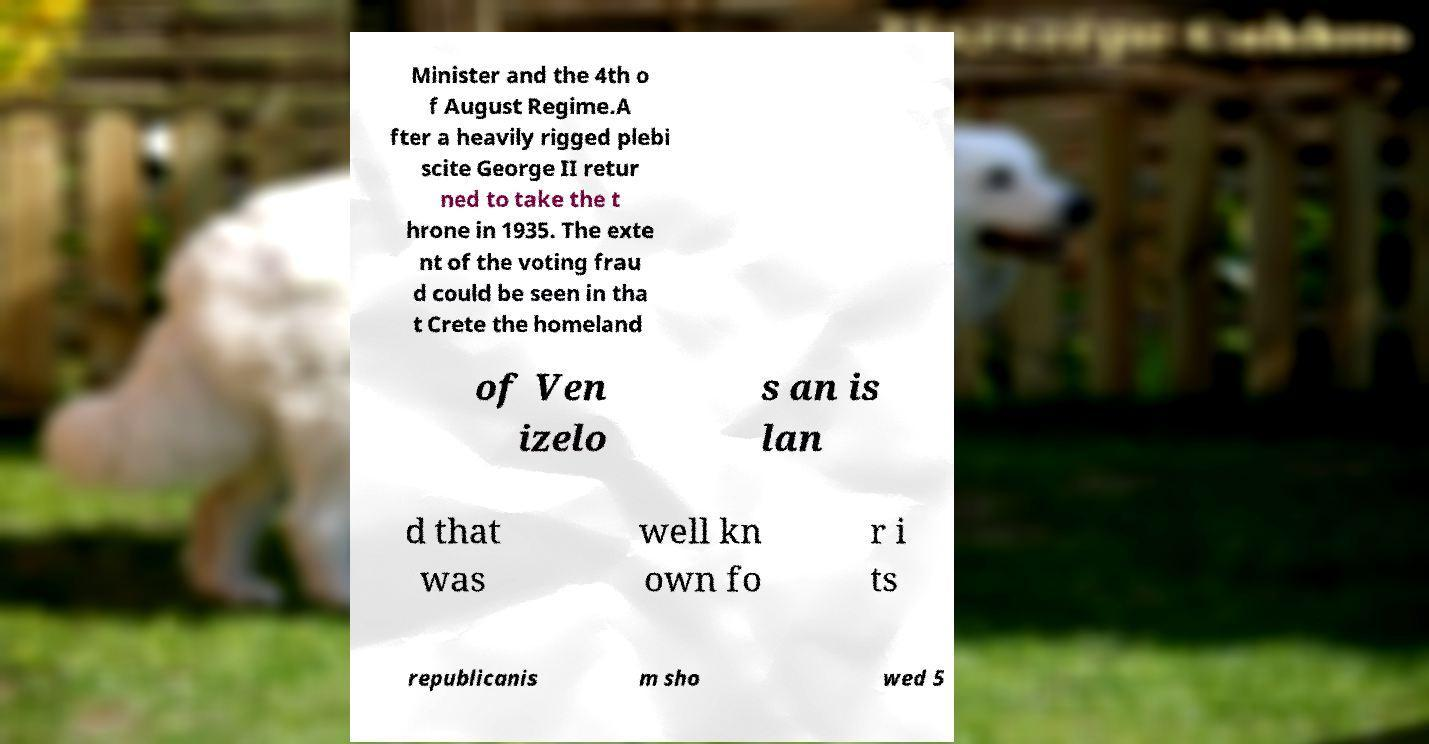I need the written content from this picture converted into text. Can you do that? Minister and the 4th o f August Regime.A fter a heavily rigged plebi scite George II retur ned to take the t hrone in 1935. The exte nt of the voting frau d could be seen in tha t Crete the homeland of Ven izelo s an is lan d that was well kn own fo r i ts republicanis m sho wed 5 